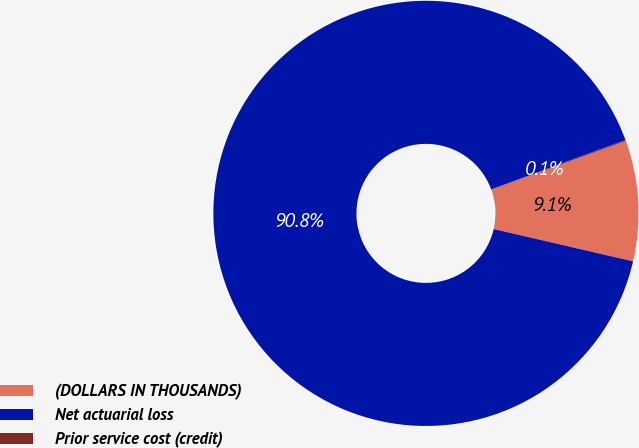Convert chart to OTSL. <chart><loc_0><loc_0><loc_500><loc_500><pie_chart><fcel>(DOLLARS IN THOUSANDS)<fcel>Net actuarial loss<fcel>Prior service cost (credit)<nl><fcel>9.15%<fcel>90.77%<fcel>0.08%<nl></chart> 